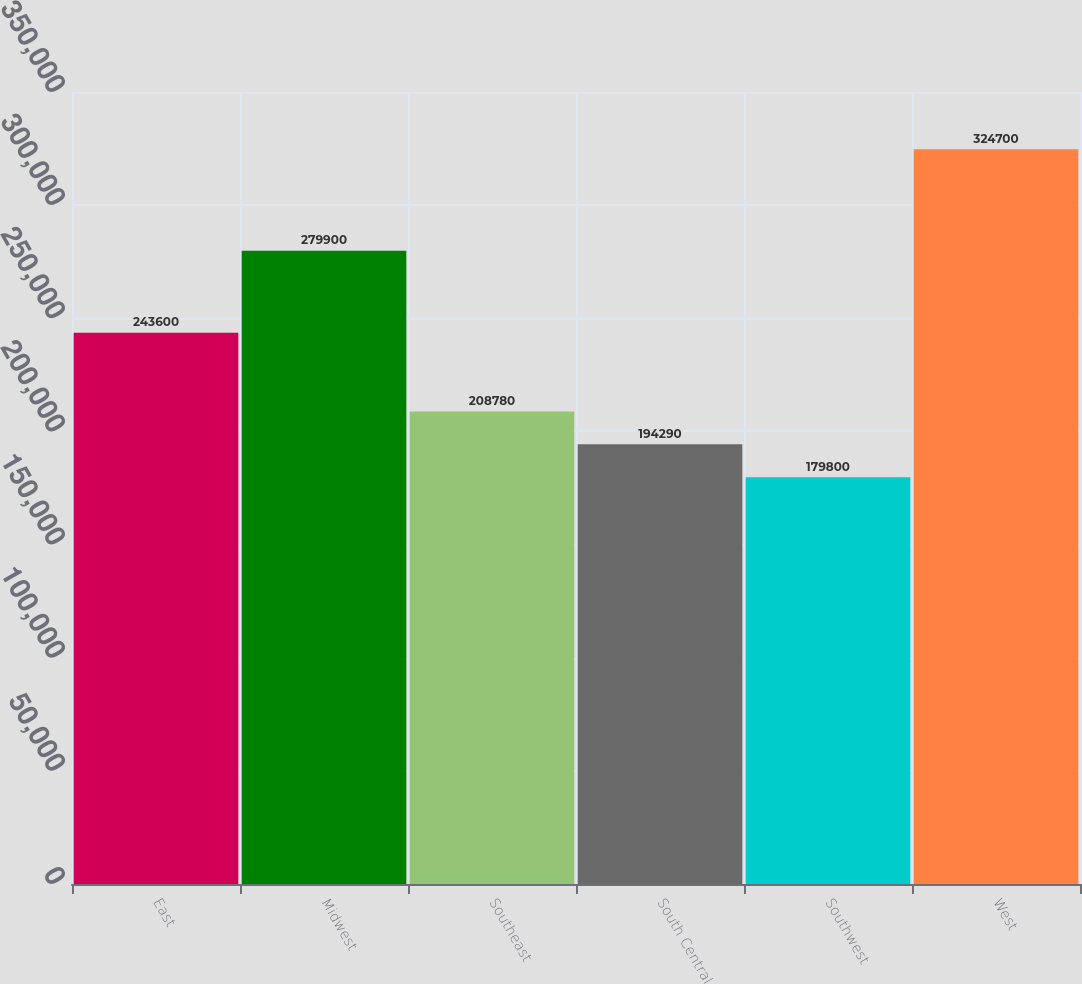<chart> <loc_0><loc_0><loc_500><loc_500><bar_chart><fcel>East<fcel>Midwest<fcel>Southeast<fcel>South Central<fcel>Southwest<fcel>West<nl><fcel>243600<fcel>279900<fcel>208780<fcel>194290<fcel>179800<fcel>324700<nl></chart> 